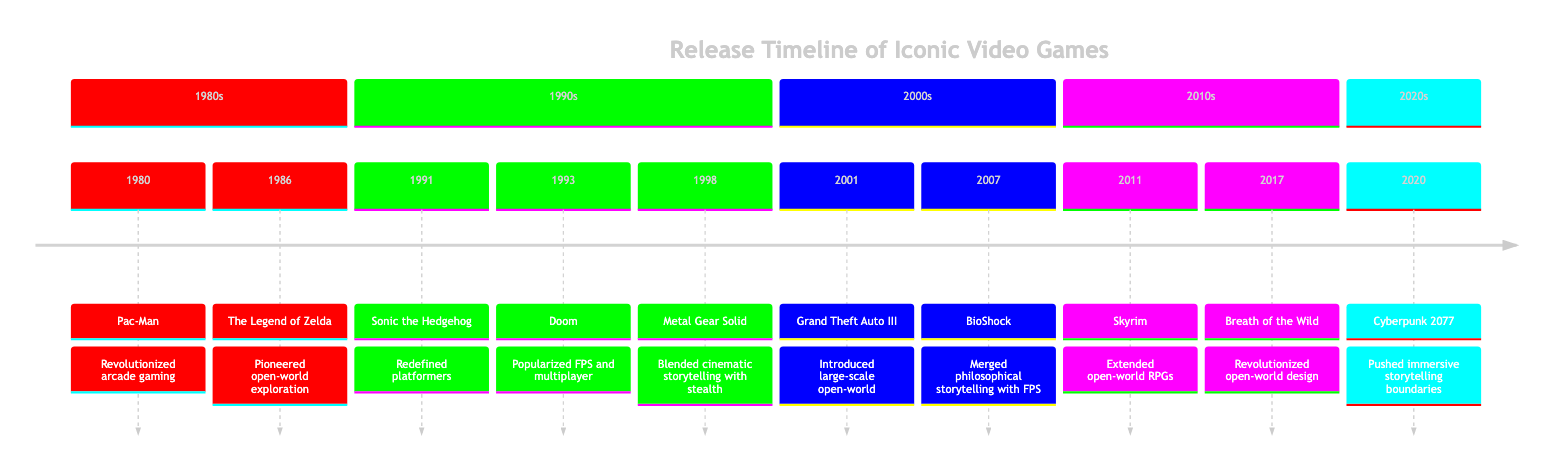What year was Pac-Man released? The diagram indicates that Pac-Man was released in 1980. I can find this information at the start of the timeline where its title and year are listed.
Answer: 1980 How many iconic video games are listed in the timeline? By counting the entries in the timeline section, I find a total of 10 iconic video games. Each game is represented by one line, making it easy to tally.
Answer: 10 Which game was released in 2001? According to the timeline, Grand Theft Auto III is listed under the year 2001. This makes it straightforward to locate the specific entry in the diagram.
Answer: Grand Theft Auto III What genre is Doom classified under? The genre associated with Doom is indicated in the diagram. Under the section for the 1990s, next to Doom, it explicitly states that it belongs to the First-Person Shooter genre.
Answer: First-Person Shooter Which video game is noted for pioneering open-world exploration? The Legend of Zelda, released in 1986, is specifically noted in the diagram for its pioneering contribution to open-world exploration. This is stated directly by its impact description.
Answer: The Legend of Zelda What impact did BioShock have on video games? The diagram mentions that BioShock merged philosophical storytelling with FPS mechanics, greatly influencing narrative depth and atmosphere. This detail can be found in the impact section of the timeline entry for BioShock.
Answer: Merged philosophical storytelling with FPS mechanics In which decade was Metal Gear Solid launched? Metal Gear Solid was released in 1998, which places it in the 1990s. By looking at the organization of the timeline, I can categorize it based on its year.
Answer: 1990s Which game is associated with the developer CD Projekt Red? Cyberpunk 2077 is the title mentioned in the timeline associated with the developer CD Projekt Red, which is clearly stated in the diagram under the entry for 2020.
Answer: Cyberpunk 2077 What was a prominent feature of Grand Theft Auto III's gameplay? The timeline notes that Grand Theft Auto III introduced open-world gameplay on a new scale, highlighting its innovative freedom in a dynamic urban environment as a defining feature.
Answer: Introduced open-world gameplay on a new scale 